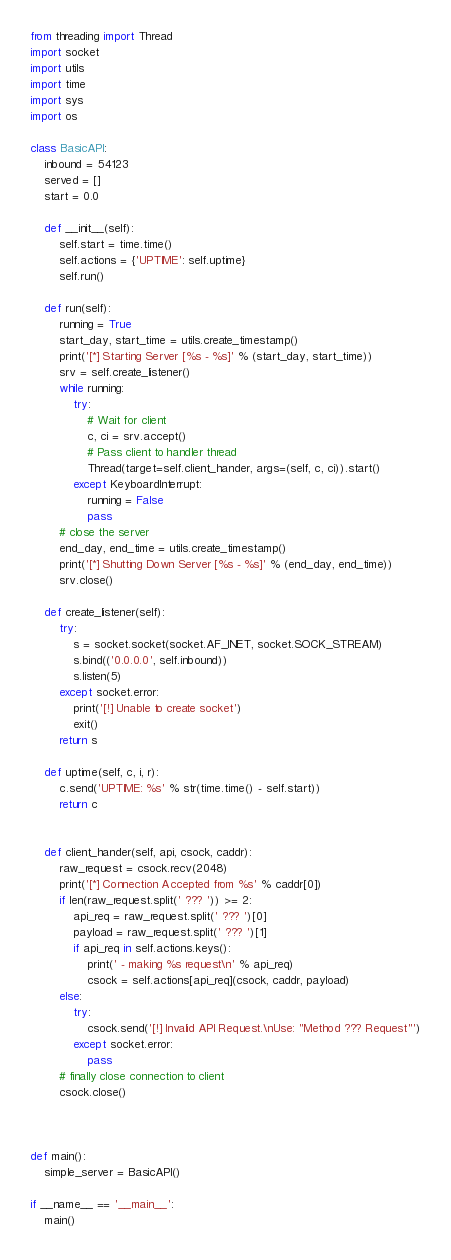Convert code to text. <code><loc_0><loc_0><loc_500><loc_500><_Python_>from threading import Thread
import socket
import utils
import time
import sys 
import os 

class BasicAPI:
	inbound = 54123
	served = []
	start = 0.0

	def __init__(self):
		self.start = time.time()
		self.actions = {'UPTIME': self.uptime}
		self.run()

	def run(self):
		running = True
		start_day, start_time = utils.create_timestamp()
		print('[*] Starting Server [%s - %s]' % (start_day, start_time))
		srv = self.create_listener()
		while running: 
			try:
				# Wait for client 
				c, ci = srv.accept()
				# Pass client to handler thread
				Thread(target=self.client_hander, args=(self, c, ci)).start()
			except KeyboardInterrupt:
				running = False
				pass
		# close the server 
		end_day, end_time = utils.create_timestamp()
		print('[*] Shutting Down Server [%s - %s]' % (end_day, end_time))
		srv.close()

	def create_listener(self):
		try:
			s = socket.socket(socket.AF_INET, socket.SOCK_STREAM)
			s.bind(('0.0.0.0', self.inbound))
			s.listen(5)
		except socket.error:
			print('[!] Unable to create socket')
			exit()
		return s

	def uptime(self, c, i, r):
		c.send('UPTIME: %s' % str(time.time() - self.start))
		return c


	def client_hander(self, api, csock, caddr):
		raw_request = csock.recv(2048)
		print('[*] Connection Accepted from %s' % caddr[0])
		if len(raw_request.split(' ??? ')) >= 2:
			api_req = raw_request.split(' ??? ')[0]
			payload = raw_request.split(' ??? ')[1]
			if api_req in self.actions.keys():
				print(' - making %s request\n' % api_req)
				csock = self.actions[api_req](csock, caddr, payload)
		else:
			try:
				csock.send('[!] Invalid API Request.\nUse: "Method ??? Request"')
			except socket.error:
				pass
		# finally close connection to client
		csock.close()



def main():
	simple_server = BasicAPI()

if __name__ == '__main__':
	main()

</code> 